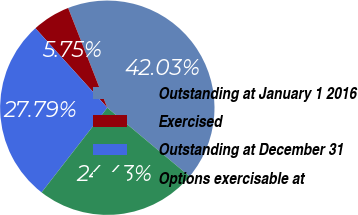Convert chart. <chart><loc_0><loc_0><loc_500><loc_500><pie_chart><fcel>Outstanding at January 1 2016<fcel>Exercised<fcel>Outstanding at December 31<fcel>Options exercisable at<nl><fcel>42.03%<fcel>5.75%<fcel>27.79%<fcel>24.43%<nl></chart> 